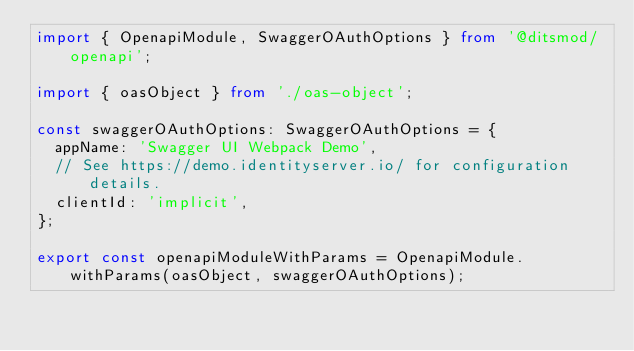<code> <loc_0><loc_0><loc_500><loc_500><_TypeScript_>import { OpenapiModule, SwaggerOAuthOptions } from '@ditsmod/openapi';

import { oasObject } from './oas-object';

const swaggerOAuthOptions: SwaggerOAuthOptions = {
  appName: 'Swagger UI Webpack Demo',
  // See https://demo.identityserver.io/ for configuration details.
  clientId: 'implicit',
};

export const openapiModuleWithParams = OpenapiModule.withParams(oasObject, swaggerOAuthOptions);
</code> 